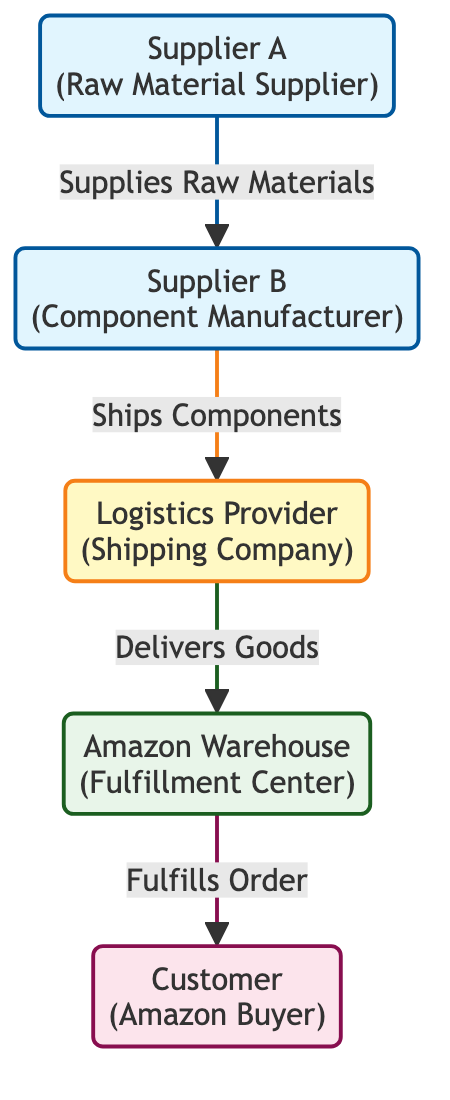What is the total number of nodes in the diagram? The diagram consists of five unique entities depicted as nodes: Supplier A, Supplier B, Logistics Provider, Amazon Warehouse, and Customer. When counted, these nodes total five.
Answer: 5 What is the relationship between Supplier A and Supplier B? Supplier A supplies raw materials to Supplier B as indicated by the directed edge connecting them with the label "Supplies Raw Materials." This direct connection defines their interaction within the supply chain.
Answer: Supplies Raw Materials Which entity fulfills the order? The Amazon Warehouse is responsible for fulfilling the order as indicated by the directed edge leading to the Customer with the label "Fulfills Order." This label signifies the final step in delivering goods to the buyer.
Answer: Amazon Warehouse Which node represents the shipping company? The node labeled "Logistics Provider" represents the shipping company in the diagram. The description specifies that it operates in shipping the components received from Supplier B.
Answer: Logistics Provider What is the flow of goods from Supplier A to the Customer? Goods flow from Supplier A to Supplier B, then to the Logistics Provider, followed by the Amazon Warehouse, and finally reaching the Customer. This sequential connection showcases the entire supply chain process leading to fulfilling the customer's order.
Answer: Supplier A → Supplier B → Logistics Provider → Amazon Warehouse → Customer How many edges are there in the diagram? There are four directed edges representing the relationships between the nodes, specifically detailing how products move through the supply chain from suppliers to the customer. Each relationship is captured as a connection between two nodes.
Answer: 4 What does the Logistics Provider do? The Logistics Provider ships components from Supplier B to the Amazon Warehouse, as described by the edge labeled "Ships Components." This role is crucial in the logistics chain to ensure that goods reach the fulfillment center.
Answer: Ships Components Which node comes after the Logistics Provider in the supply chain? The node that follows the Logistics Provider is the Amazon Warehouse, as indicated by the arrow leading to it, which denotes the delivery of goods from the logistics company. This step is essential in the distribution process.
Answer: Amazon Warehouse What type of entity is Supplier A? Supplier A is classified as a "Raw Material Supplier" within the supply chain diagram. This designation clarifies its role in providing the necessary materials to the next stage in the manufacturing process.
Answer: Raw Material Supplier 